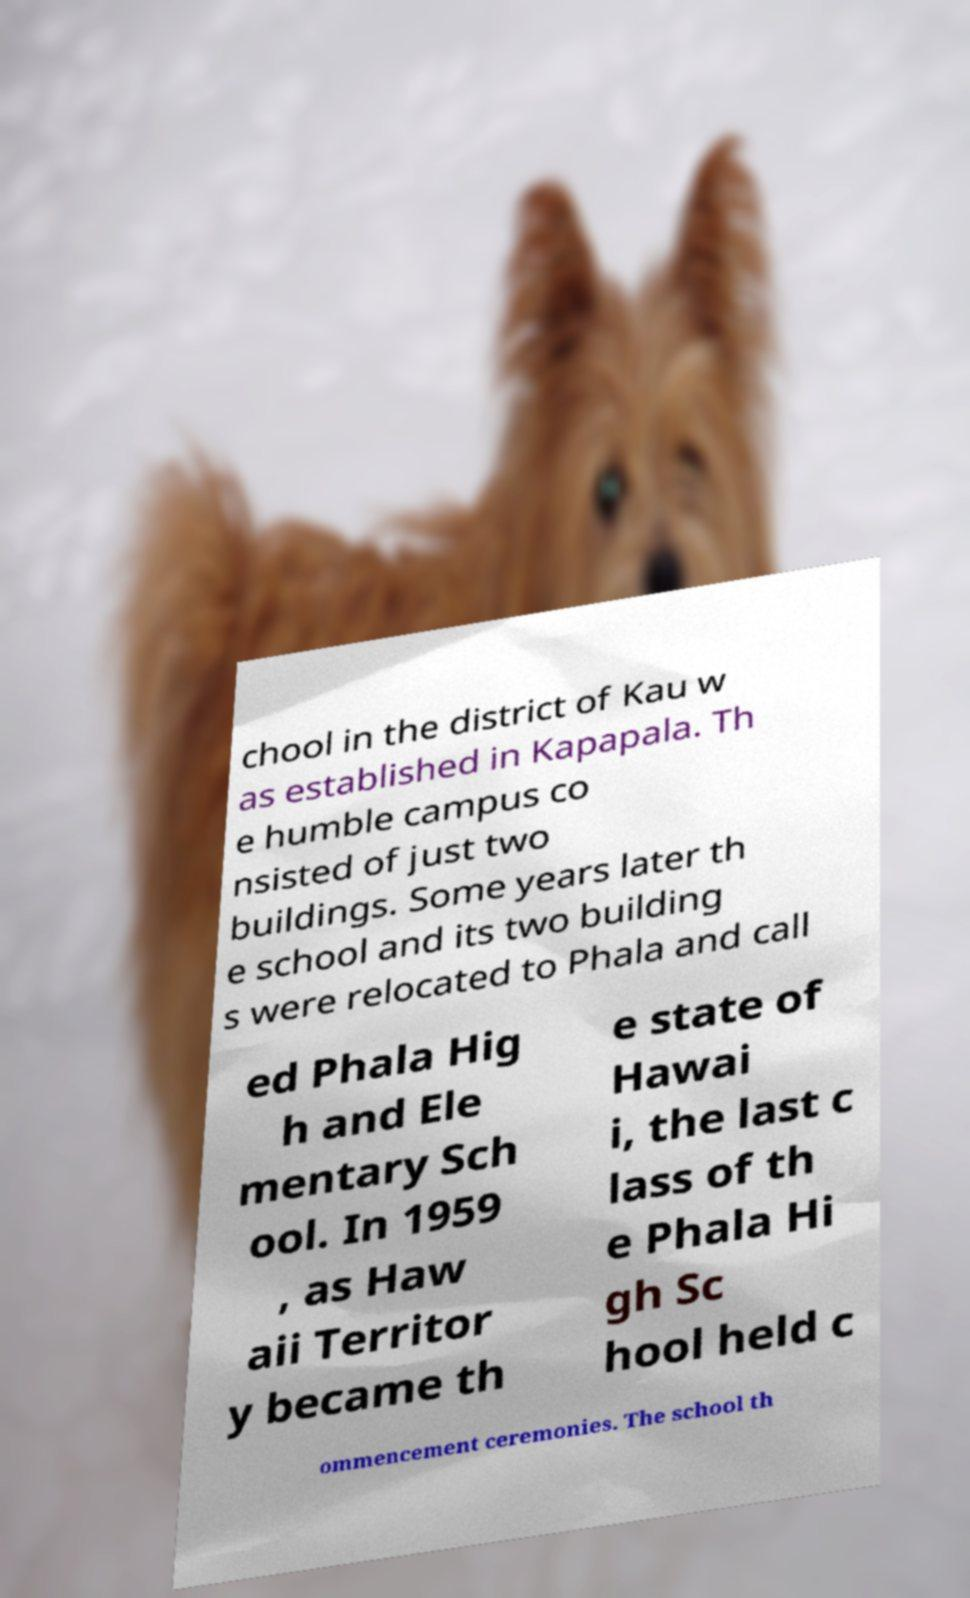What messages or text are displayed in this image? I need them in a readable, typed format. chool in the district of Kau w as established in Kapapala. Th e humble campus co nsisted of just two buildings. Some years later th e school and its two building s were relocated to Phala and call ed Phala Hig h and Ele mentary Sch ool. In 1959 , as Haw aii Territor y became th e state of Hawai i, the last c lass of th e Phala Hi gh Sc hool held c ommencement ceremonies. The school th 